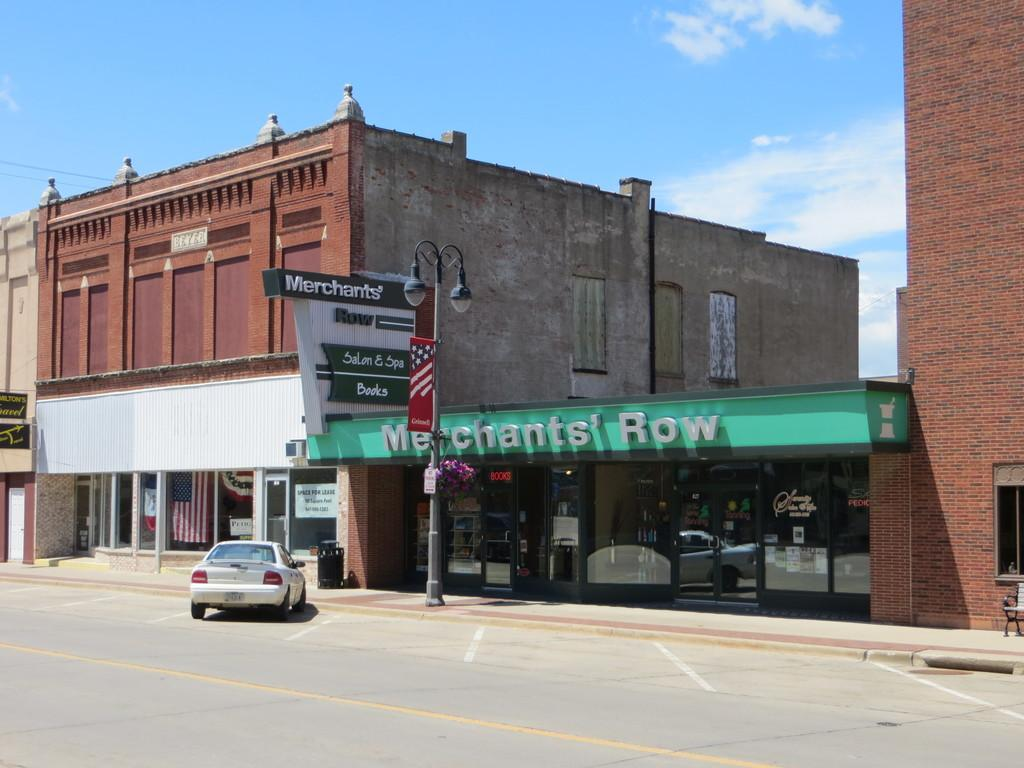What is parked on the side of the road in the image? There is a car parked on the side of the road in the image. What type of object can be seen near the car? There is a dustbin in the image. What type of structures are visible in the image? There are buildings in the image, including brick buildings. What type of lighting is present in the image? There are light poles in the image. What type of decorations are present in the image? There are banners in the image. What can be seen in the background of the image? The sky is visible in the background of the image, with clouds present. How does the car grip the road in the image? The car does not grip the road in the image; it is parked and not in motion. What type of board is visible on the side of the brick building? There is no board visible on the side of the brick building in the image. 